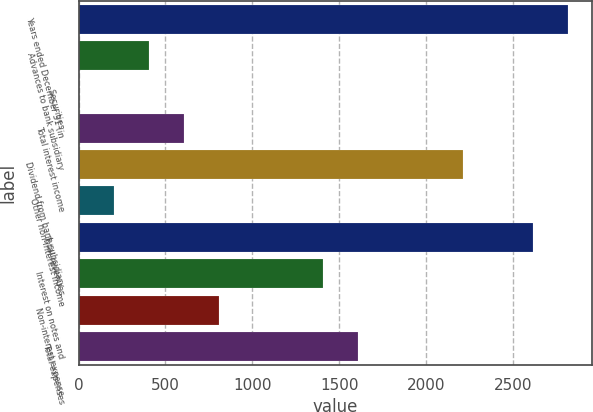Convert chart. <chart><loc_0><loc_0><loc_500><loc_500><bar_chart><fcel>Years ended December 31 (in<fcel>Advances to bank subsidiary<fcel>Securities<fcel>Total interest income<fcel>Dividend from bank subsidiary<fcel>Other non-interest income<fcel>Total revenues<fcel>Interest on notes and<fcel>Non-interest expense<fcel>Total expenses<nl><fcel>2818.08<fcel>402.84<fcel>0.3<fcel>604.11<fcel>2214.27<fcel>201.57<fcel>2616.81<fcel>1409.19<fcel>805.38<fcel>1610.46<nl></chart> 